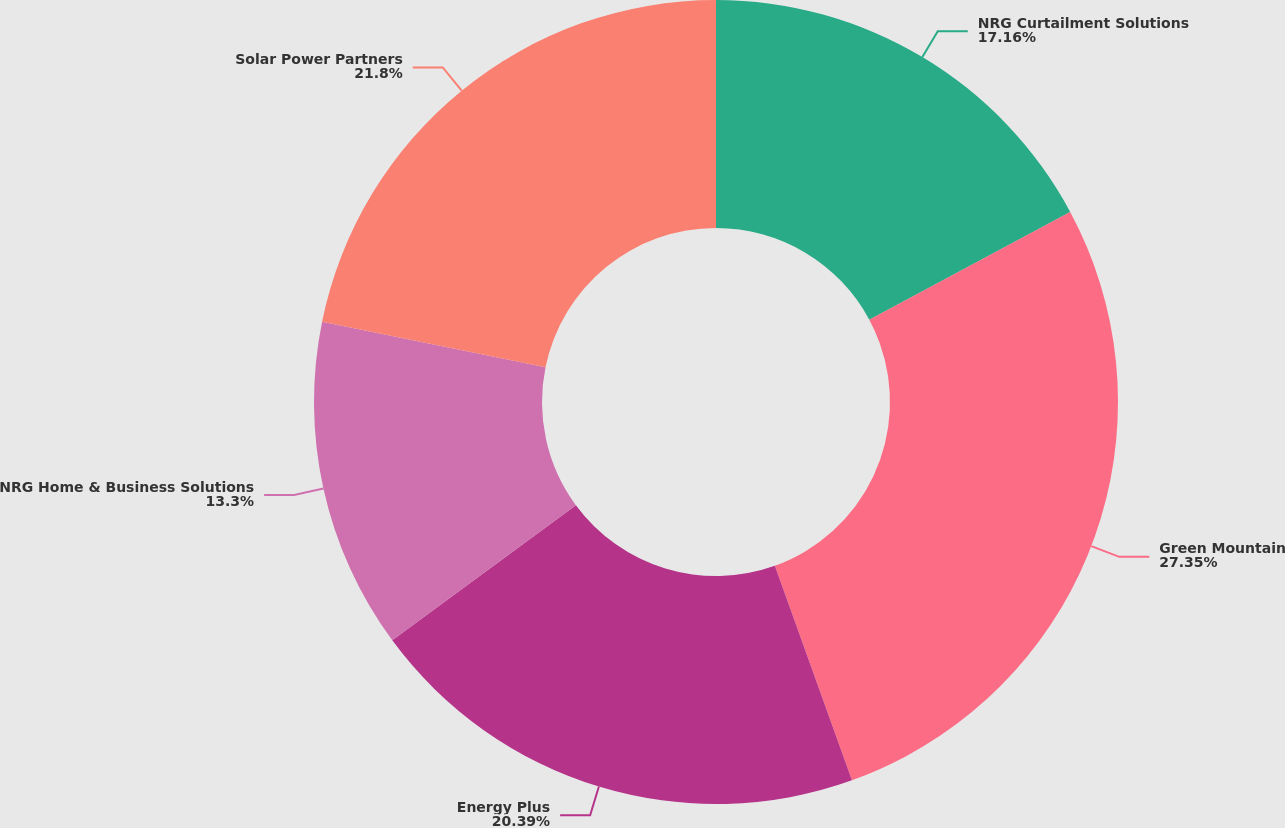<chart> <loc_0><loc_0><loc_500><loc_500><pie_chart><fcel>NRG Curtailment Solutions<fcel>Green Mountain<fcel>Energy Plus<fcel>NRG Home & Business Solutions<fcel>Solar Power Partners<nl><fcel>17.16%<fcel>27.35%<fcel>20.39%<fcel>13.3%<fcel>21.8%<nl></chart> 